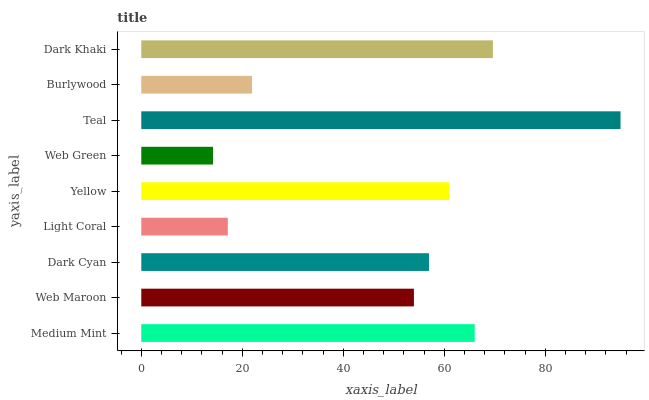Is Web Green the minimum?
Answer yes or no. Yes. Is Teal the maximum?
Answer yes or no. Yes. Is Web Maroon the minimum?
Answer yes or no. No. Is Web Maroon the maximum?
Answer yes or no. No. Is Medium Mint greater than Web Maroon?
Answer yes or no. Yes. Is Web Maroon less than Medium Mint?
Answer yes or no. Yes. Is Web Maroon greater than Medium Mint?
Answer yes or no. No. Is Medium Mint less than Web Maroon?
Answer yes or no. No. Is Dark Cyan the high median?
Answer yes or no. Yes. Is Dark Cyan the low median?
Answer yes or no. Yes. Is Light Coral the high median?
Answer yes or no. No. Is Web Green the low median?
Answer yes or no. No. 